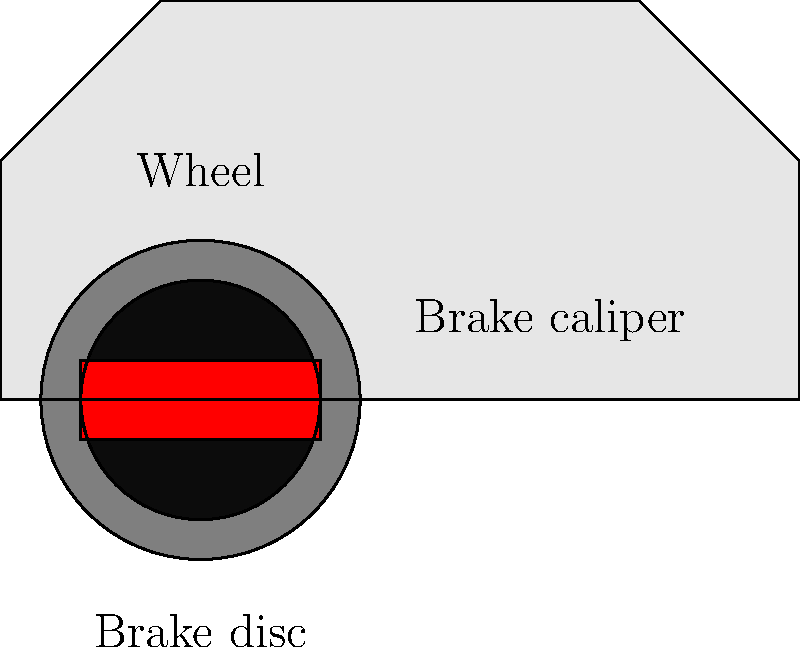In a Turismo Carretera race, a car weighing 1200 kg is traveling at 180 km/h when the driver applies the brakes, bringing the car to a complete stop in 4 seconds. Using the work-energy principle and considering the braking system shown in the diagram, calculate the average braking force applied to stop the car. Assume the track is level and neglect air resistance. Let's approach this step-by-step using the work-energy principle:

1) First, we need to convert the initial speed from km/h to m/s:
   $180 \text{ km/h} = 180 \times \frac{1000 \text{ m}}{3600 \text{ s}} = 50 \text{ m/s}$

2) The work-energy principle states that the work done on an object is equal to its change in kinetic energy:
   $W = \Delta KE = KE_f - KE_i$

3) Initial kinetic energy:
   $KE_i = \frac{1}{2}mv_i^2 = \frac{1}{2} \times 1200 \text{ kg} \times (50 \text{ m/s})^2 = 1,500,000 \text{ J}$

4) Final kinetic energy (car at rest):
   $KE_f = 0 \text{ J}$

5) Work done by the braking force:
   $W = \Delta KE = 0 - 1,500,000 \text{ J} = -1,500,000 \text{ J}$

6) Work is also equal to force times distance:
   $W = F \times d$

7) We don't know the distance, but we can find it using the equation of motion for constant acceleration:
   $v_f^2 = v_i^2 + 2ad$
   $0 = (50 \text{ m/s})^2 + 2a \times d$
   $d = \frac{(50 \text{ m/s})^2}{-2a}$

8) We can find the acceleration using $v_f = v_i + at$:
   $0 = 50 \text{ m/s} + a \times 4 \text{ s}$
   $a = -12.5 \text{ m/s}^2$

9) Now we can find the distance:
   $d = \frac{(50 \text{ m/s})^2}{2 \times 12.5 \text{ m/s}^2} = 100 \text{ m}$

10) Using the work equation:
    $-1,500,000 \text{ J} = F \times 100 \text{ m}$
    $F = -15,000 \text{ N}$

The negative sign indicates the force is in the opposite direction of motion. The magnitude of the average braking force is 15,000 N.
Answer: 15,000 N 